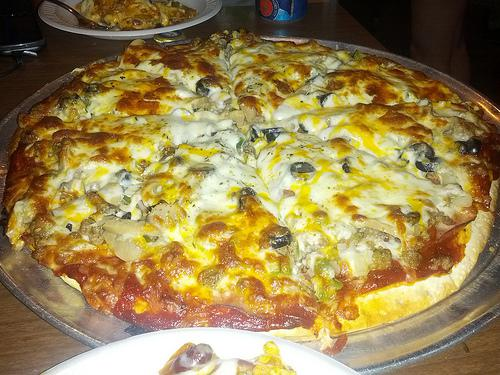Question: where is a small white plate?
Choices:
A. The store.
B. In the sink.
C. On the table.
D. The left.
Answer with the letter. Answer: D Question: what color is the huge pizza plate?
Choices:
A. White.
B. Silver.
C. Black.
D. Grey.
Answer with the letter. Answer: B 